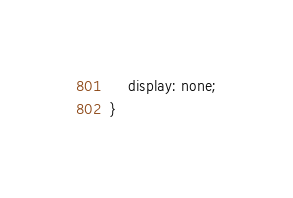Convert code to text. <code><loc_0><loc_0><loc_500><loc_500><_CSS_>    display: none;
}</code> 